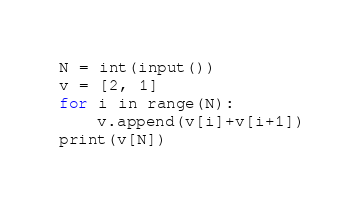<code> <loc_0><loc_0><loc_500><loc_500><_Python_>N = int(input())
v = [2, 1]
for i in range(N):
	v.append(v[i]+v[i+1])
print(v[N])
</code> 